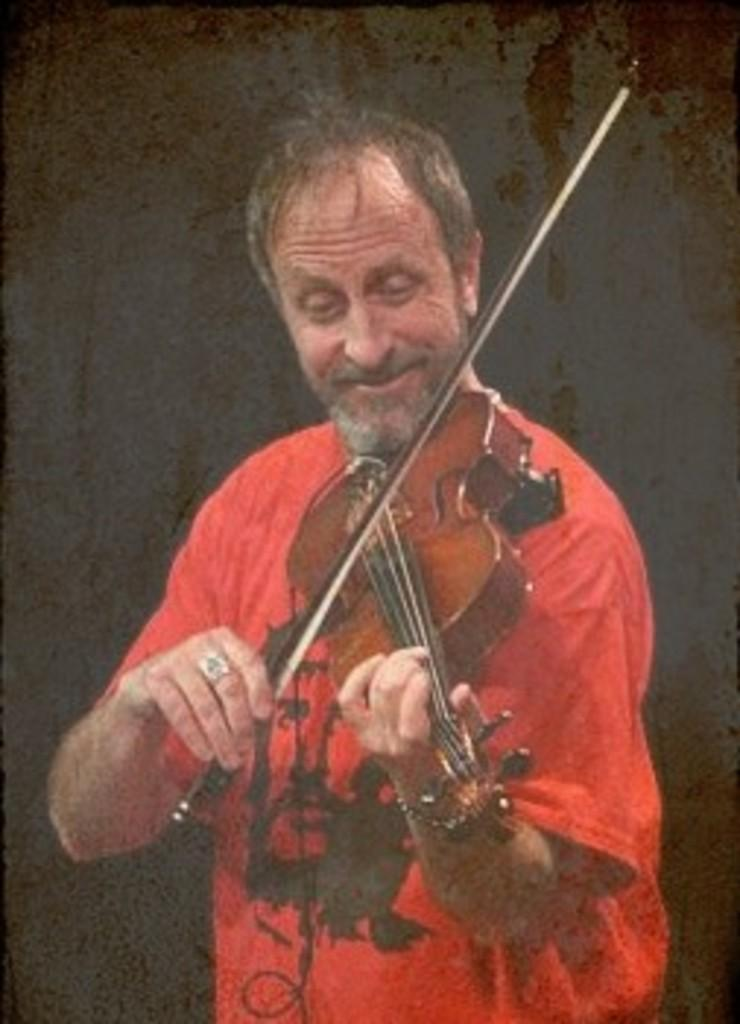What is the man in the image doing? The man is playing the violin. What is the man wearing in the image? The man is wearing a red t-shirt. How is the man feeling in the image? The man is smiling, which suggests he is happy or enjoying himself. What is the color of the background in the image? The background of the image is black in color. What type of fang can be seen in the man's mouth in the image? There are no fangs visible in the man's mouth in the image. What type of jeans is the man wearing in the image? The man is not wearing jeans in the image; he is wearing a red t-shirt. 